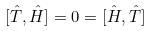<formula> <loc_0><loc_0><loc_500><loc_500>[ \hat { T } , \hat { H } ] = 0 = [ \hat { H } , \hat { T } ]</formula> 